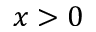Convert formula to latex. <formula><loc_0><loc_0><loc_500><loc_500>x > 0</formula> 